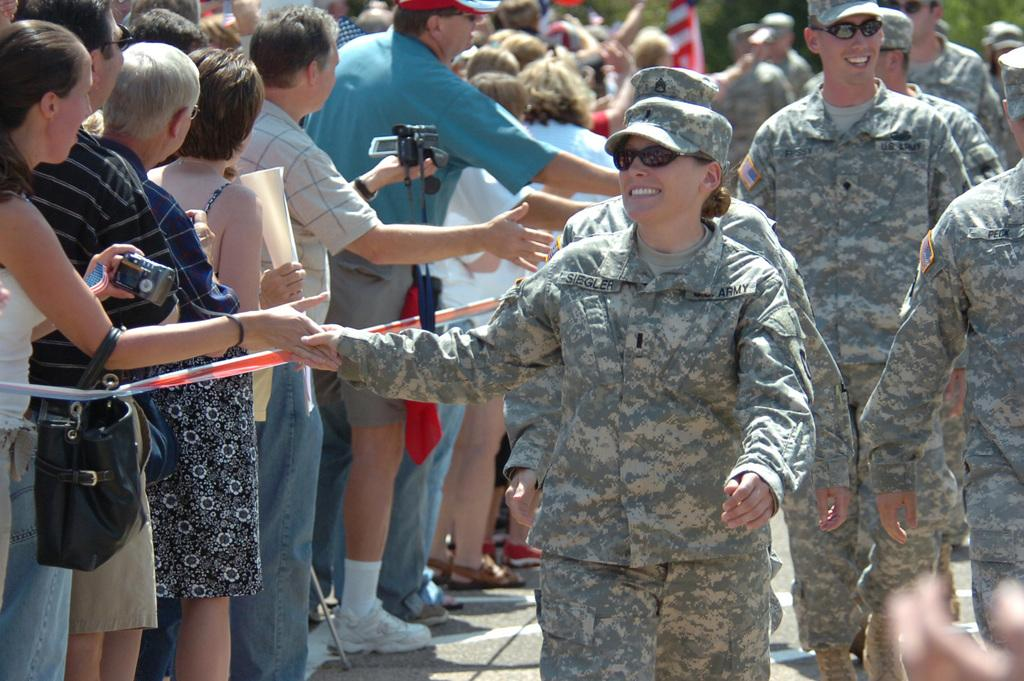What is the main subject of the image? The main subject of the image is a group of people. Can you describe the attire of some people in the image? Some people on the right side are wearing army dresses. Who is holding a camera in the image? There is a person holding a camera in the image. What type of tooth can be seen in the image? There is no tooth present in the image. Can you describe the tongue of the person holding the camera? There is no tongue visible in the image, as the person holding the camera is not shown in a way that would reveal their tongue. 